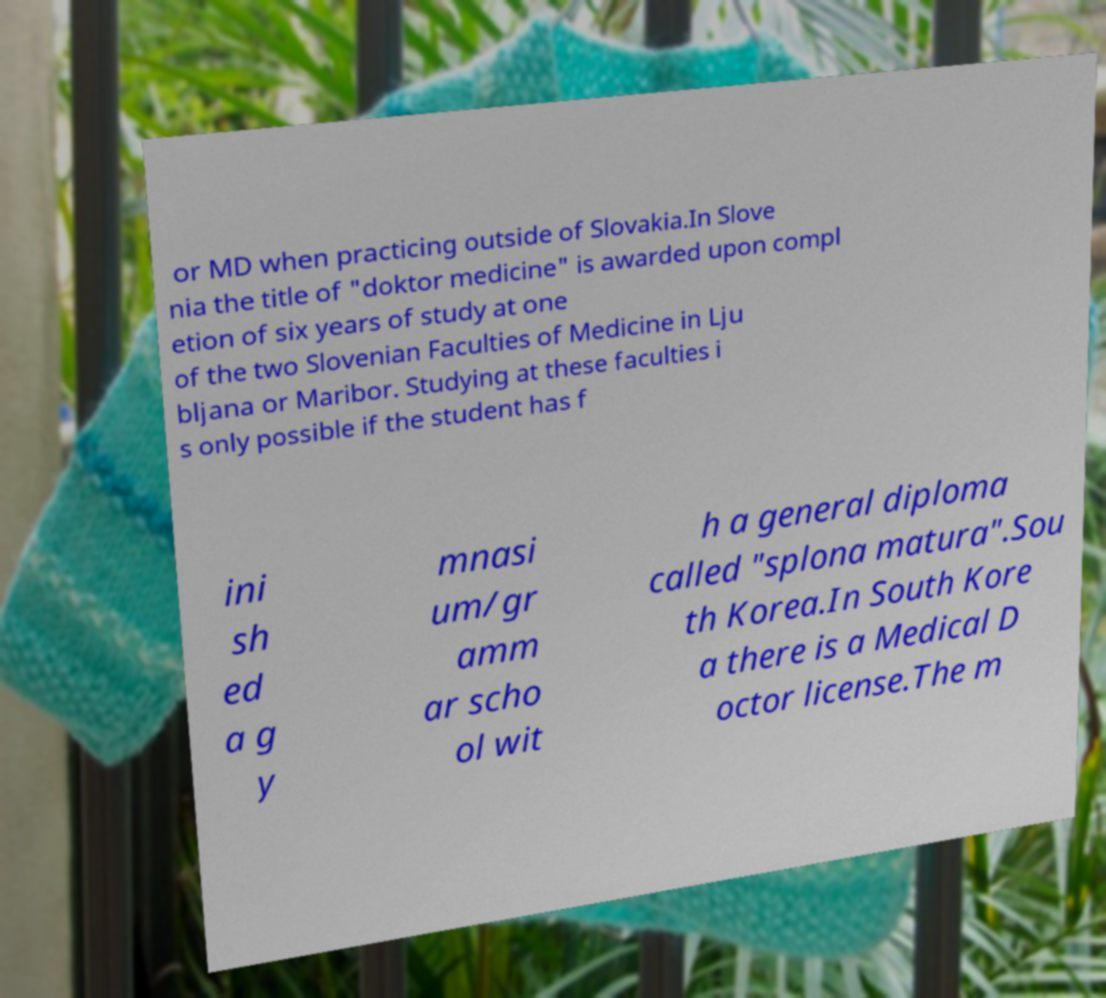Please read and relay the text visible in this image. What does it say? or MD when practicing outside of Slovakia.In Slove nia the title of "doktor medicine" is awarded upon compl etion of six years of study at one of the two Slovenian Faculties of Medicine in Lju bljana or Maribor. Studying at these faculties i s only possible if the student has f ini sh ed a g y mnasi um/gr amm ar scho ol wit h a general diploma called "splona matura".Sou th Korea.In South Kore a there is a Medical D octor license.The m 